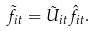Convert formula to latex. <formula><loc_0><loc_0><loc_500><loc_500>\tilde { f } _ { i t } = \tilde { U } _ { i t } \hat { f } _ { i t } .</formula> 